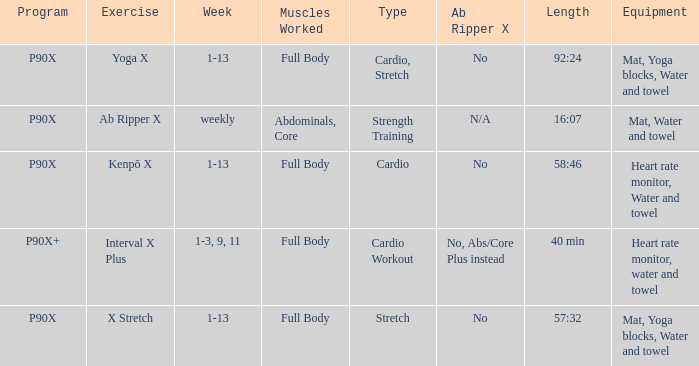What is the week when type is cardio workout? 1-3, 9, 11. 